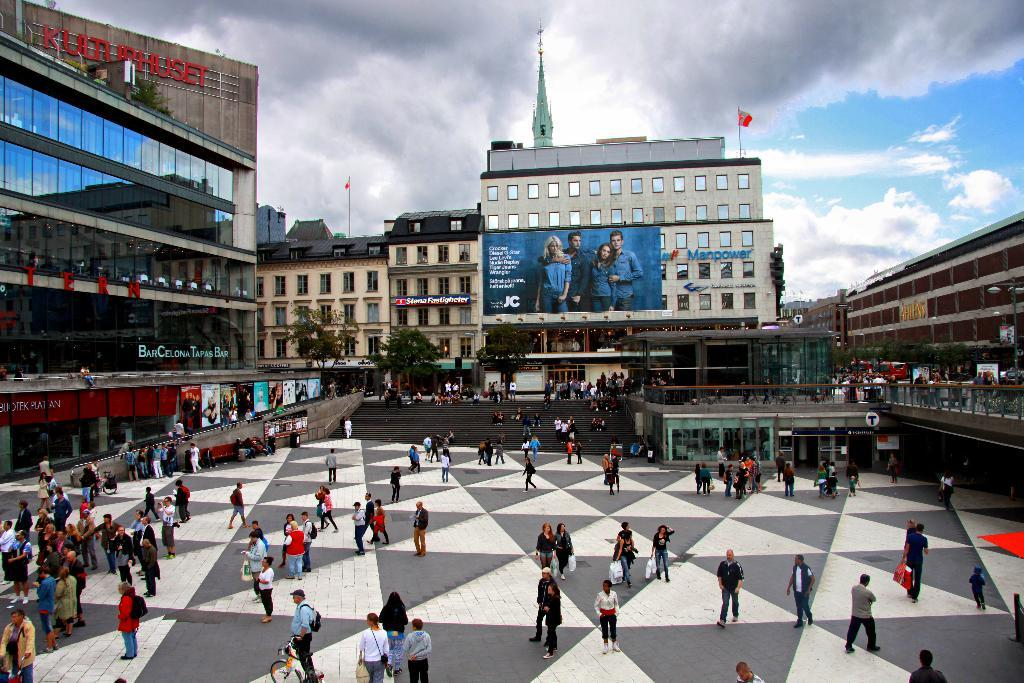What are the people in the image doing? The people in the image are walking on the land. Can you describe the gender of the people in the image? There are men and women in the image. What can be seen in the background of the image? There are buildings, trees, and clouds in the sky in the background of the image. What type of cherry is being used as a hat by the monkey in the image? There is no monkey or cherry present in the image. How many eggs are visible on the ground in the image? There are no eggs visible on the ground in the image. 